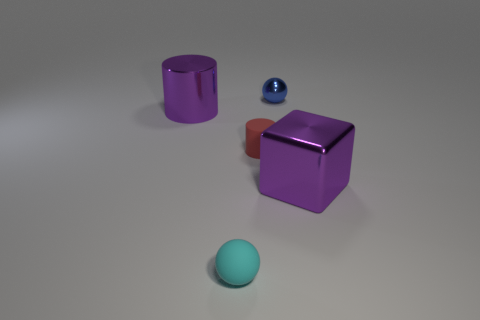The ball that is in front of the purple thing left of the cyan matte thing is what color?
Give a very brief answer. Cyan. There is a small rubber ball; is its color the same as the large shiny object left of the small cyan matte ball?
Give a very brief answer. No. There is a big thing that is to the left of the large purple thing on the right side of the matte ball; what number of purple metallic cylinders are in front of it?
Provide a short and direct response. 0. There is a cube; are there any tiny matte spheres behind it?
Your response must be concise. No. Are there any other things that are the same color as the large cylinder?
Your answer should be compact. Yes. What number of cubes are either purple metallic things or blue metallic objects?
Your response must be concise. 1. How many small balls are in front of the blue metallic ball and behind the small cyan rubber ball?
Give a very brief answer. 0. Are there the same number of rubber things to the left of the cyan sphere and blue spheres that are on the left side of the red cylinder?
Provide a short and direct response. Yes. There is a purple object that is left of the tiny cyan thing; does it have the same shape as the small metal object?
Offer a terse response. No. There is a purple object that is on the left side of the big purple metal thing to the right of the metal thing that is left of the tiny cyan rubber sphere; what is its shape?
Offer a very short reply. Cylinder. 